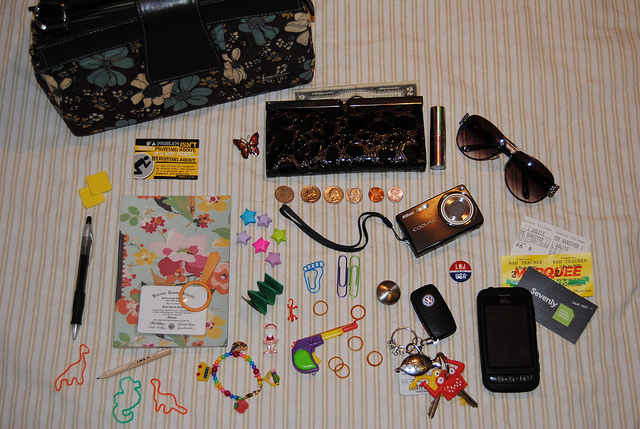What might be the possible activities the owner of these items is involved with? The owner of these items might be engaged in a variety of activities. The camera and the mobile phone suggest an interest in photography or staying connected with others. The presence of sunglasses and keys indicate travel or routine outdoor activities. The collection of personal care and decorative items like the hair clip and bracelet can imply an attention to personal appearance and style. 